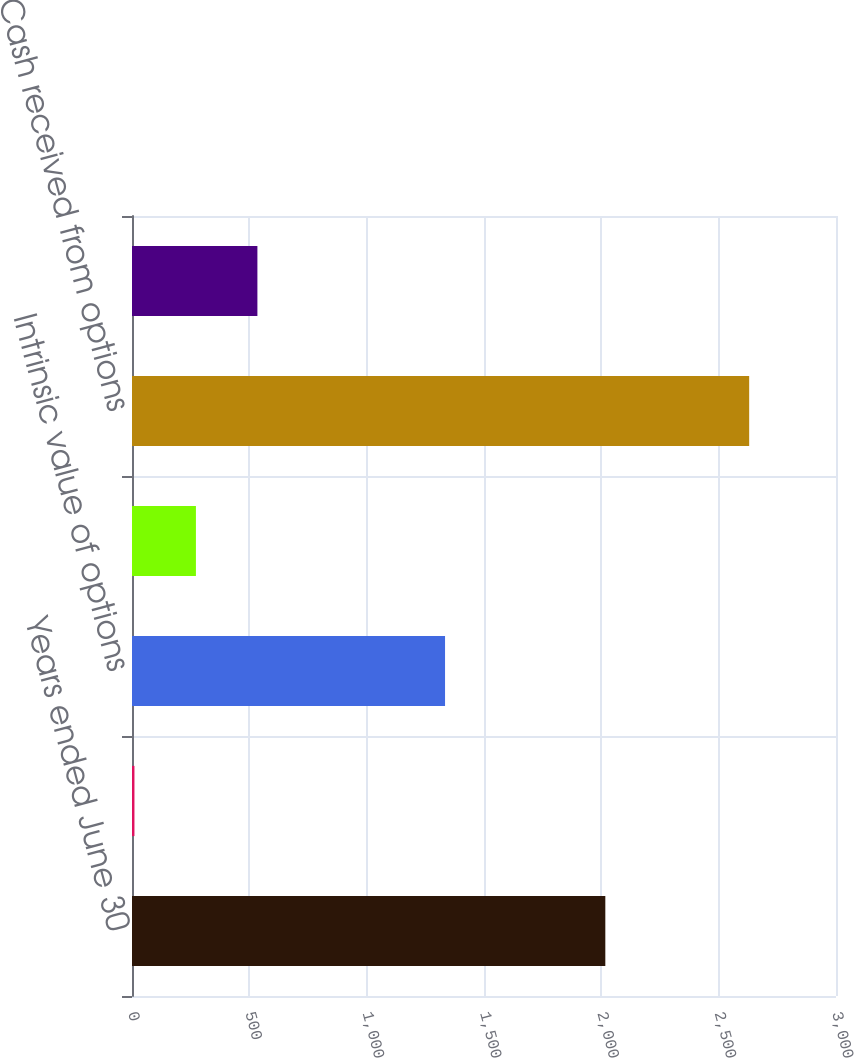<chart> <loc_0><loc_0><loc_500><loc_500><bar_chart><fcel>Years ended June 30<fcel>Weighted average grant-date<fcel>Intrinsic value of options<fcel>Grant-date fair value of<fcel>Cash received from options<fcel>Actual tax benefit from<nl><fcel>2017<fcel>10.45<fcel>1334<fcel>272.41<fcel>2630<fcel>534.37<nl></chart> 